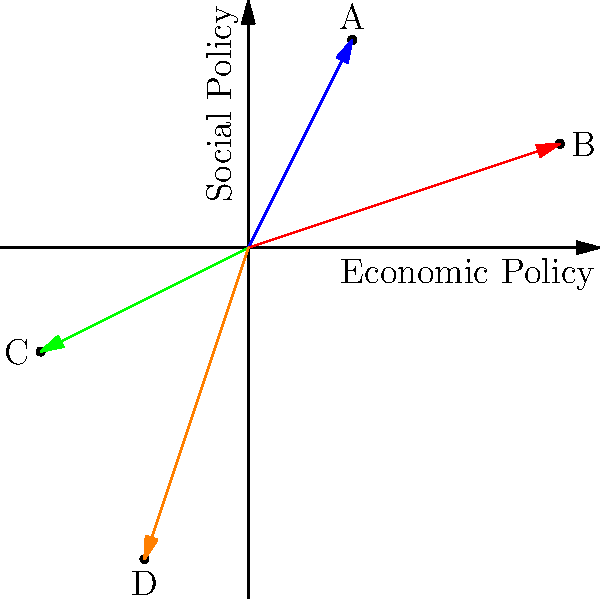In a 2D political spectrum analysis, four politicians (A, B, C, and D) are represented by vectors from the origin. Given that the x-axis represents economic policy (positive is more conservative) and the y-axis represents social policy (positive is more liberal), which politician's stance is most closely aligned with a moderate centrist position? Assume a centrist position is represented by the vector $\vec{c} = (0.5, 0.5)$. To determine which politician is most closely aligned with a moderate centrist position, we need to calculate the dot product of each politician's vector with the centrist vector $\vec{c} = (0.5, 0.5)$. The politician whose vector has the largest dot product with $\vec{c}$ will be the most closely aligned.

Let's calculate the dot product for each politician:

1. Politician A: $\vec{a} = (1, 2)$
   $\vec{a} \cdot \vec{c} = (1 \times 0.5) + (2 \times 0.5) = 0.5 + 1 = 1.5$

2. Politician B: $\vec{b} = (3, 1)$
   $\vec{b} \cdot \vec{c} = (3 \times 0.5) + (1 \times 0.5) = 1.5 + 0.5 = 2$

3. Politician C: $\vec{c} = (-2, -1)$
   $\vec{c} \cdot \vec{c} = (-2 \times 0.5) + (-1 \times 0.5) = -1 - 0.5 = -1.5$

4. Politician D: $\vec{d} = (-1, -3)$
   $\vec{d} \cdot \vec{c} = (-1 \times 0.5) + (-3 \times 0.5) = -0.5 - 1.5 = -2$

The largest dot product is 2, corresponding to Politician B. This means that Politician B's stance is most closely aligned with the moderate centrist position.
Answer: Politician B 